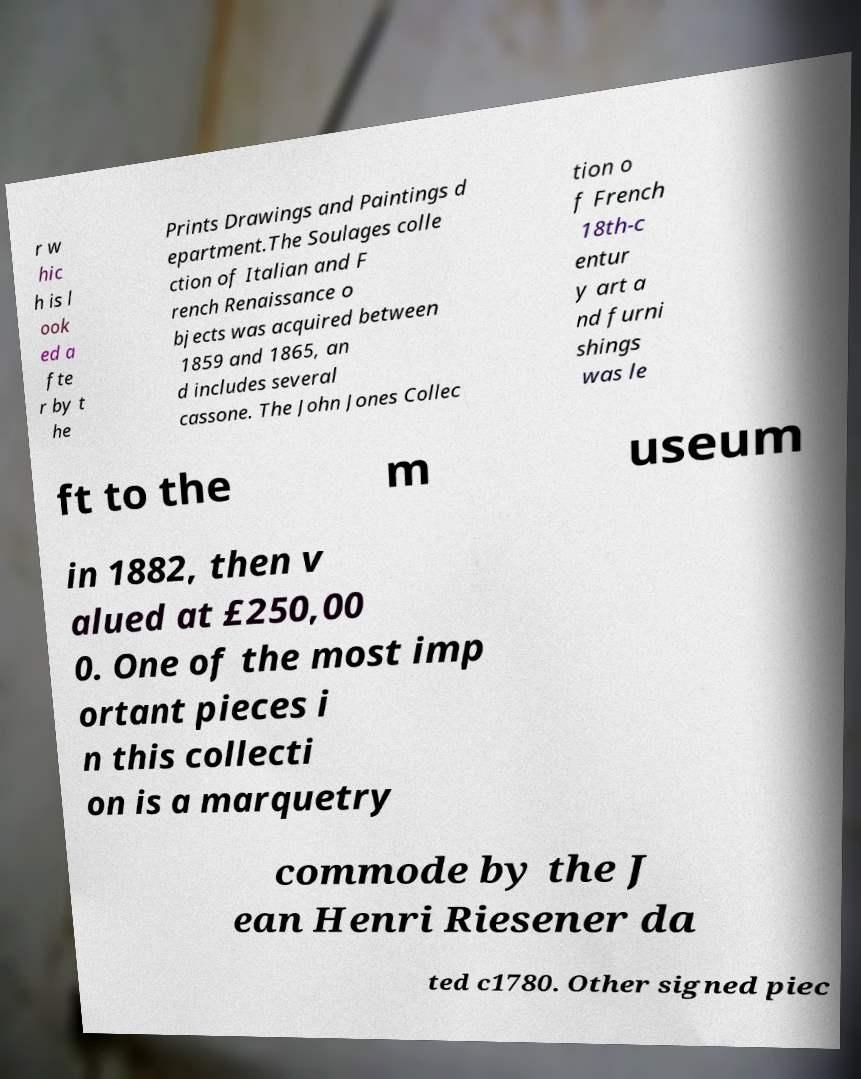Please identify and transcribe the text found in this image. r w hic h is l ook ed a fte r by t he Prints Drawings and Paintings d epartment.The Soulages colle ction of Italian and F rench Renaissance o bjects was acquired between 1859 and 1865, an d includes several cassone. The John Jones Collec tion o f French 18th-c entur y art a nd furni shings was le ft to the m useum in 1882, then v alued at £250,00 0. One of the most imp ortant pieces i n this collecti on is a marquetry commode by the J ean Henri Riesener da ted c1780. Other signed piec 